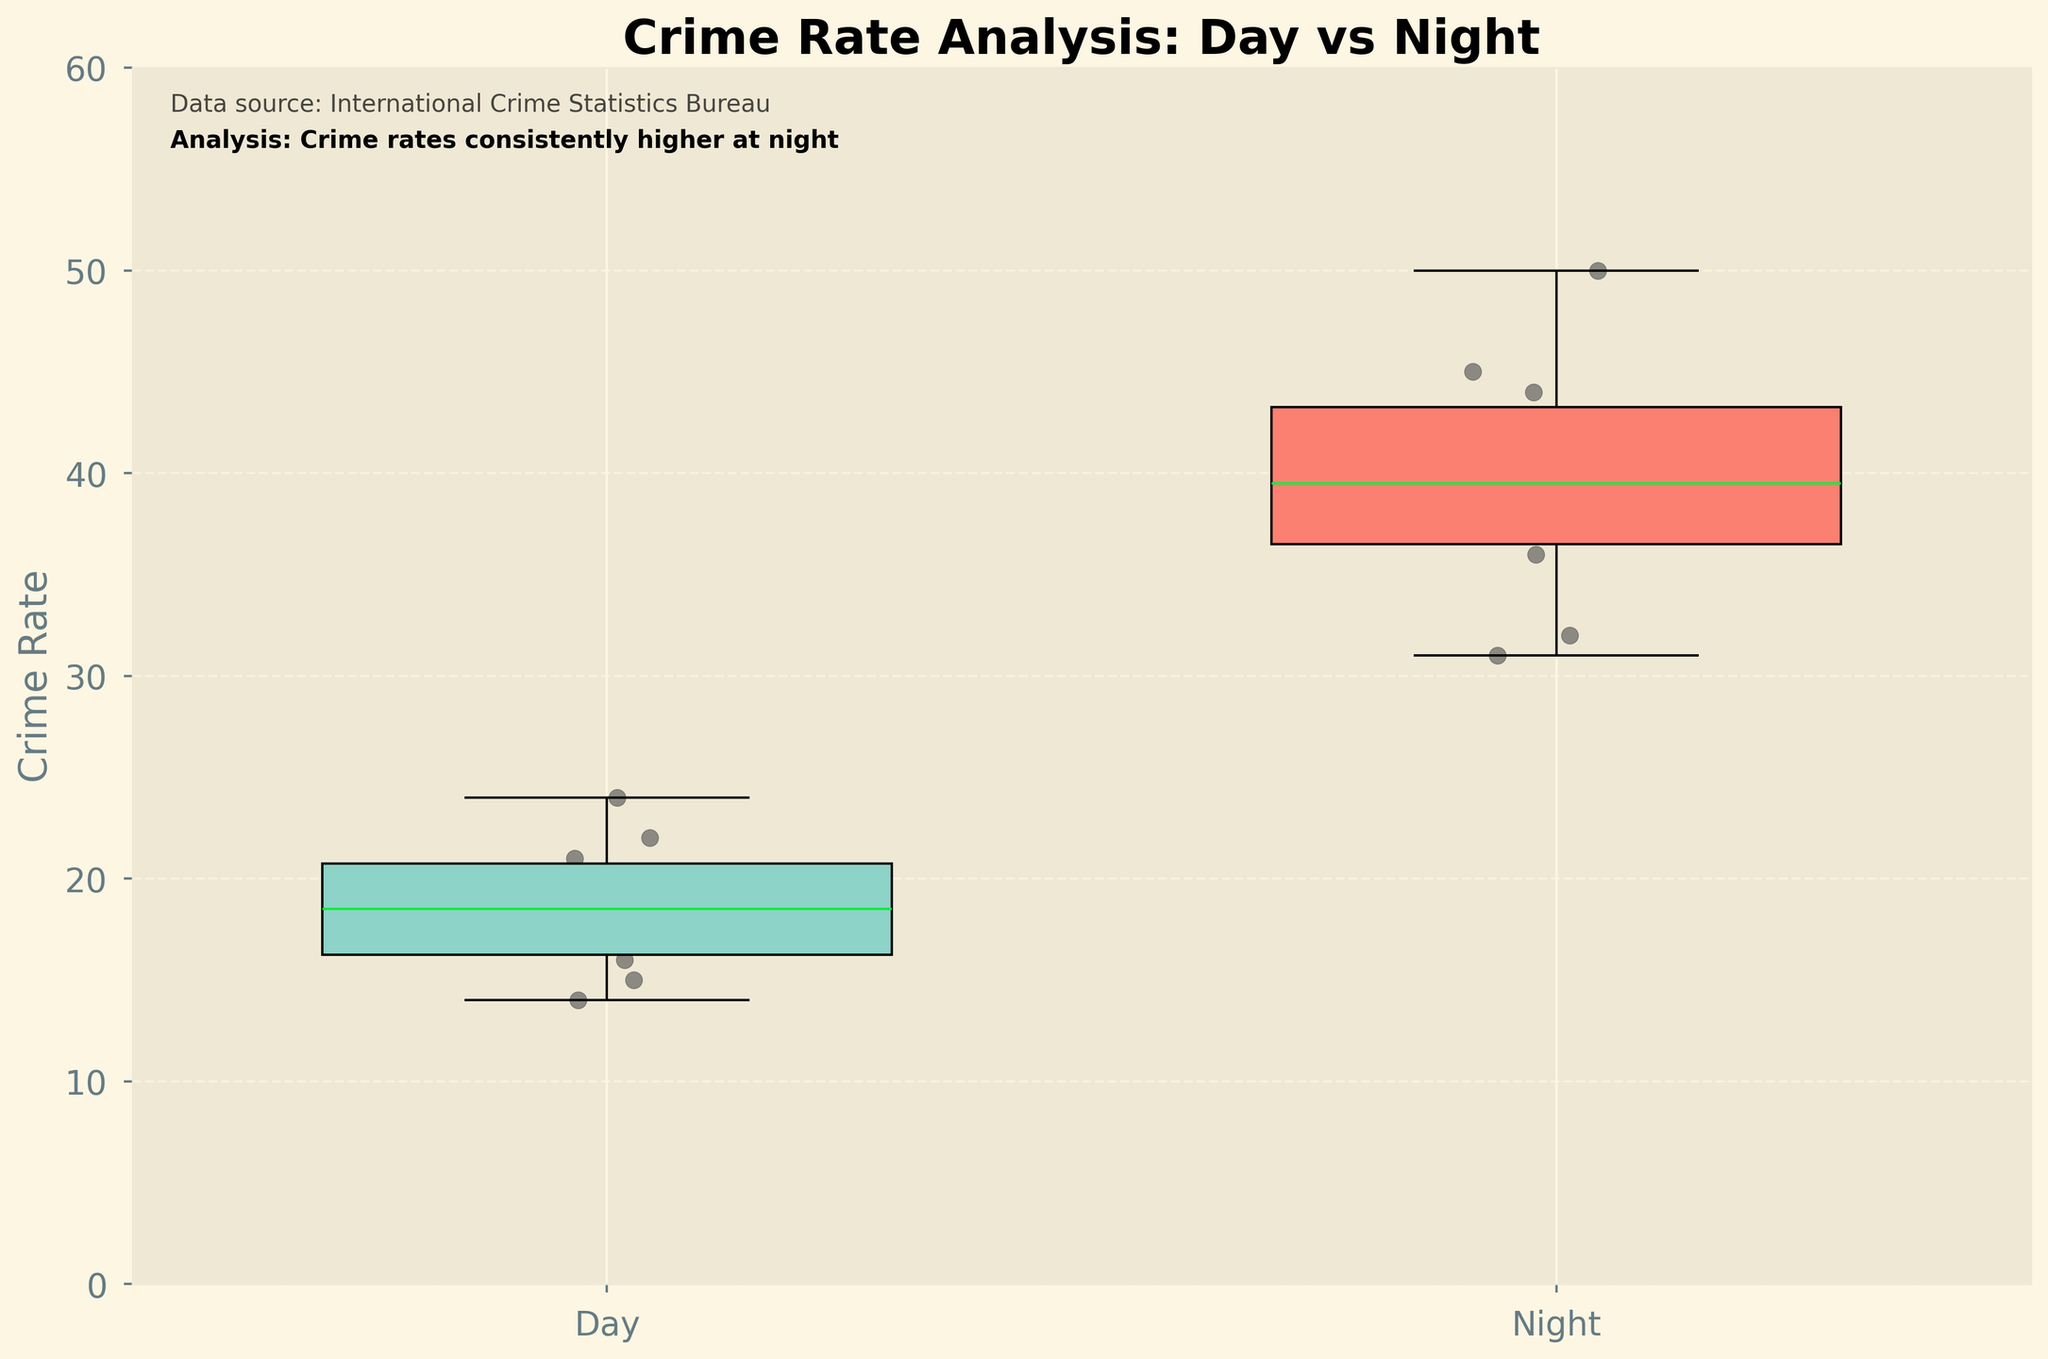what is the title of this plot? The title of a plot is usually found at the top and provides a summary of the main focus of the plot. Here, it is bold and mentions the nature of the plot.
Answer: Crime Rate Analysis: Day vs Night what does the y-axis represent? The y-axis usually represents the measure used in the plot. Here, it is labeled, giving the measure being used to compare daytime and nighttime.
Answer: Crime Rate what do the colors of the box plots represent? The two colors in the box plots represent different groups. The light green color represents one group and the light red represents another. These colors provide a visual differentiation between daytime and nighttime data.
Answer: Day and Night which time period has the higher median crime rate? To determine this, one needs to look at the median line inside the boxes of each group. The line inside the nighttime box is higher than the one inside the daytime box.
Answer: Night what is the range of crime rates for the daytime? The range can be observed as the distance between the bottom and top of the "whiskers" (lines extending from the boxes) for the daytime group.
Answer: 14 to 24 how does the variability of crime rate compare between daytime and nighttime? Variability in a box plot is shown by the size of the box and the length of the whiskers. The nighttime group has a larger box and longer whiskers, indicating higher variability.
Answer: Night has higher variability how many cities are included in this plot? Each dot represents a data point corresponding to a city's crime rate, and each city has two dots - one for day and one for night. By counting the dots for one time period, you get the number of cities.
Answer: 10 what does the text annotation at the bottom left convey? There are details given in text on the plot. The first line mentions the source of the data and the second line provides a summarized insight derived from the plot.
Answer: Data source and analysis summary does the plot show any outliers? Outliers in box plots are shown as points outside the whiskers (1.5 times the interquartile range). The plot doesn't have any points outside the whiskers for either group.
Answer: No how much greater is the median crime rate at night compared to the day? To find this, locate the median line in each box plot and read the values. Subtract the median of the day from the median of the night.
Answer: 20 